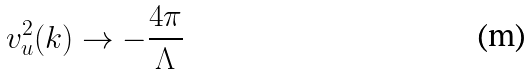<formula> <loc_0><loc_0><loc_500><loc_500>v _ { u } ^ { 2 } ( k ) \rightarrow - \frac { 4 \pi } { \Lambda }</formula> 